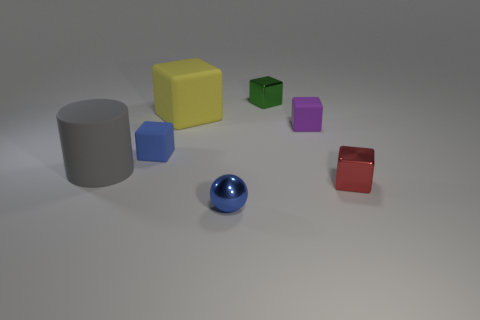Add 3 small blue metal things. How many objects exist? 10 Subtract all blocks. How many objects are left? 2 Subtract all big yellow rubber blocks. Subtract all yellow cubes. How many objects are left? 5 Add 3 large gray things. How many large gray things are left? 4 Add 6 small blue cubes. How many small blue cubes exist? 7 Subtract 1 green cubes. How many objects are left? 6 